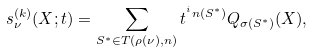<formula> <loc_0><loc_0><loc_500><loc_500>s _ { \nu } ^ { ( k ) } ( X ; t ) = \sum _ { S ^ { * } \in T ( \rho ( \nu ) , n ) } t ^ { ^ { i } n ( S ^ { * } ) } Q _ { \sigma ( S ^ { * } ) } ( X ) ,</formula> 